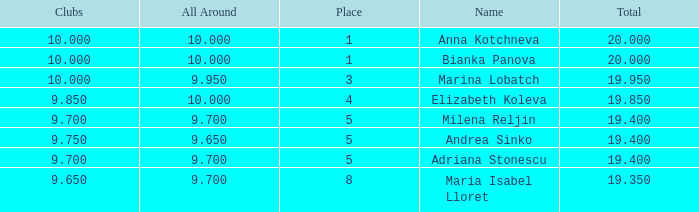How many places have bianka panova as the name, with clubs less than 10? 0.0. 